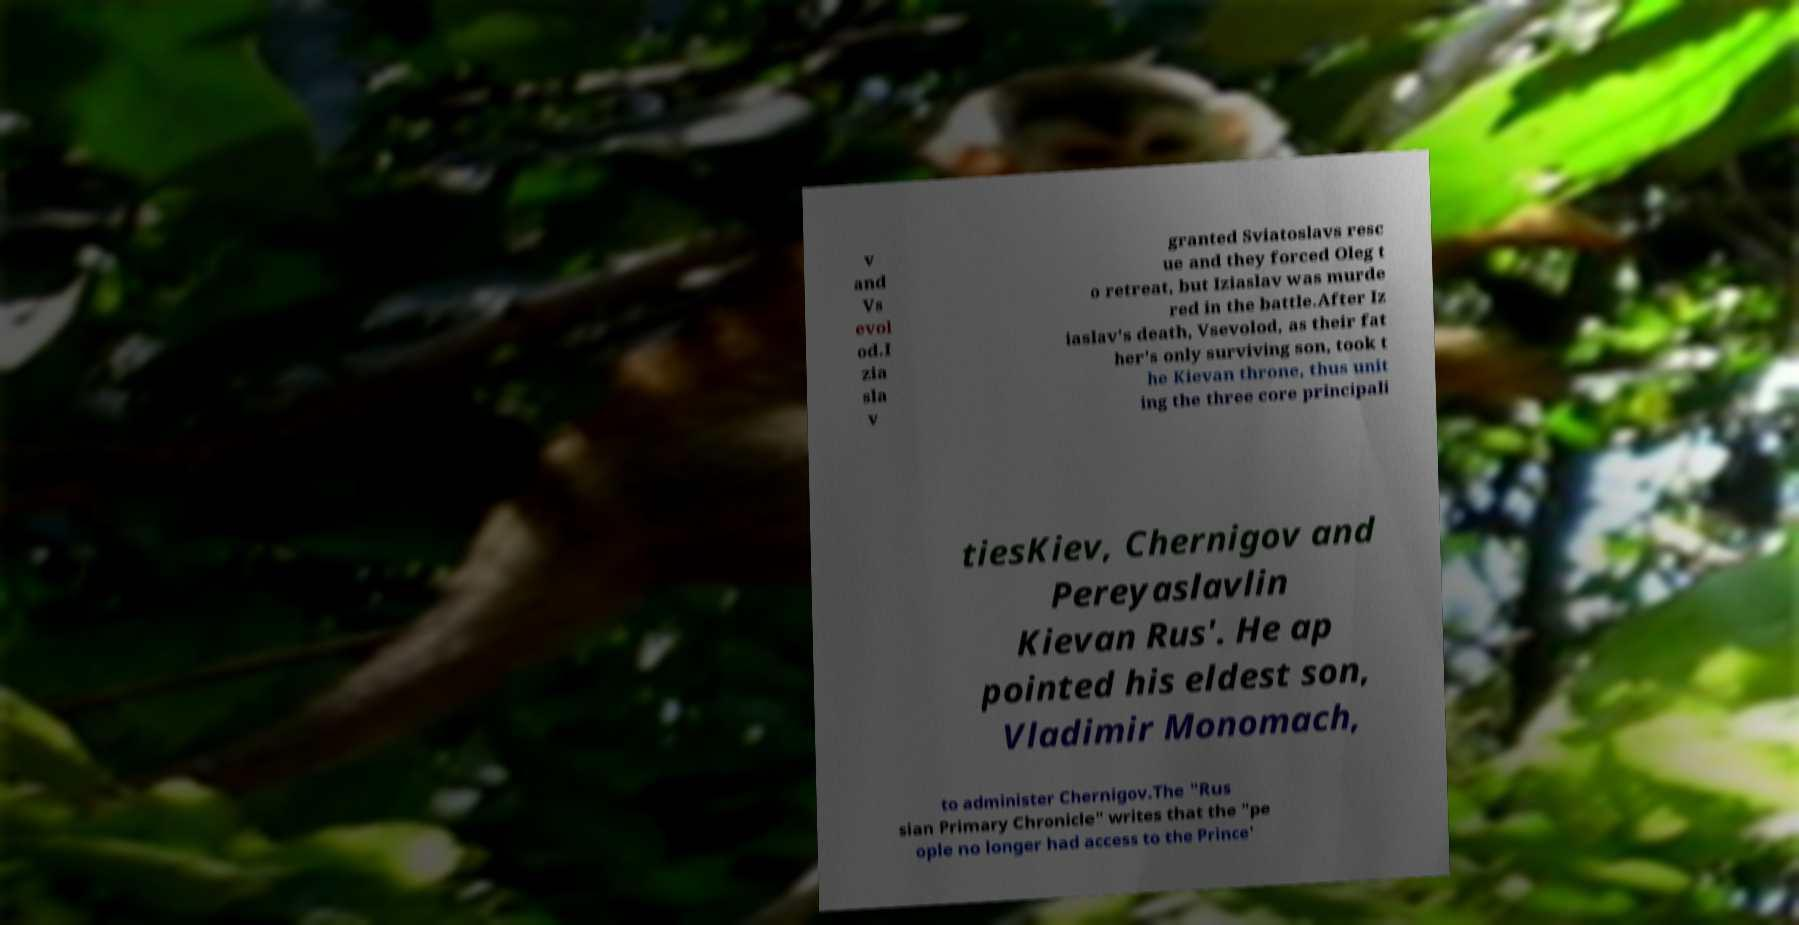Could you extract and type out the text from this image? v and Vs evol od.I zia sla v granted Sviatoslavs resc ue and they forced Oleg t o retreat, but Iziaslav was murde red in the battle.After Iz iaslav's death, Vsevolod, as their fat her's only surviving son, took t he Kievan throne, thus unit ing the three core principali tiesKiev, Chernigov and Pereyaslavlin Kievan Rus'. He ap pointed his eldest son, Vladimir Monomach, to administer Chernigov.The "Rus sian Primary Chronicle" writes that the "pe ople no longer had access to the Prince' 